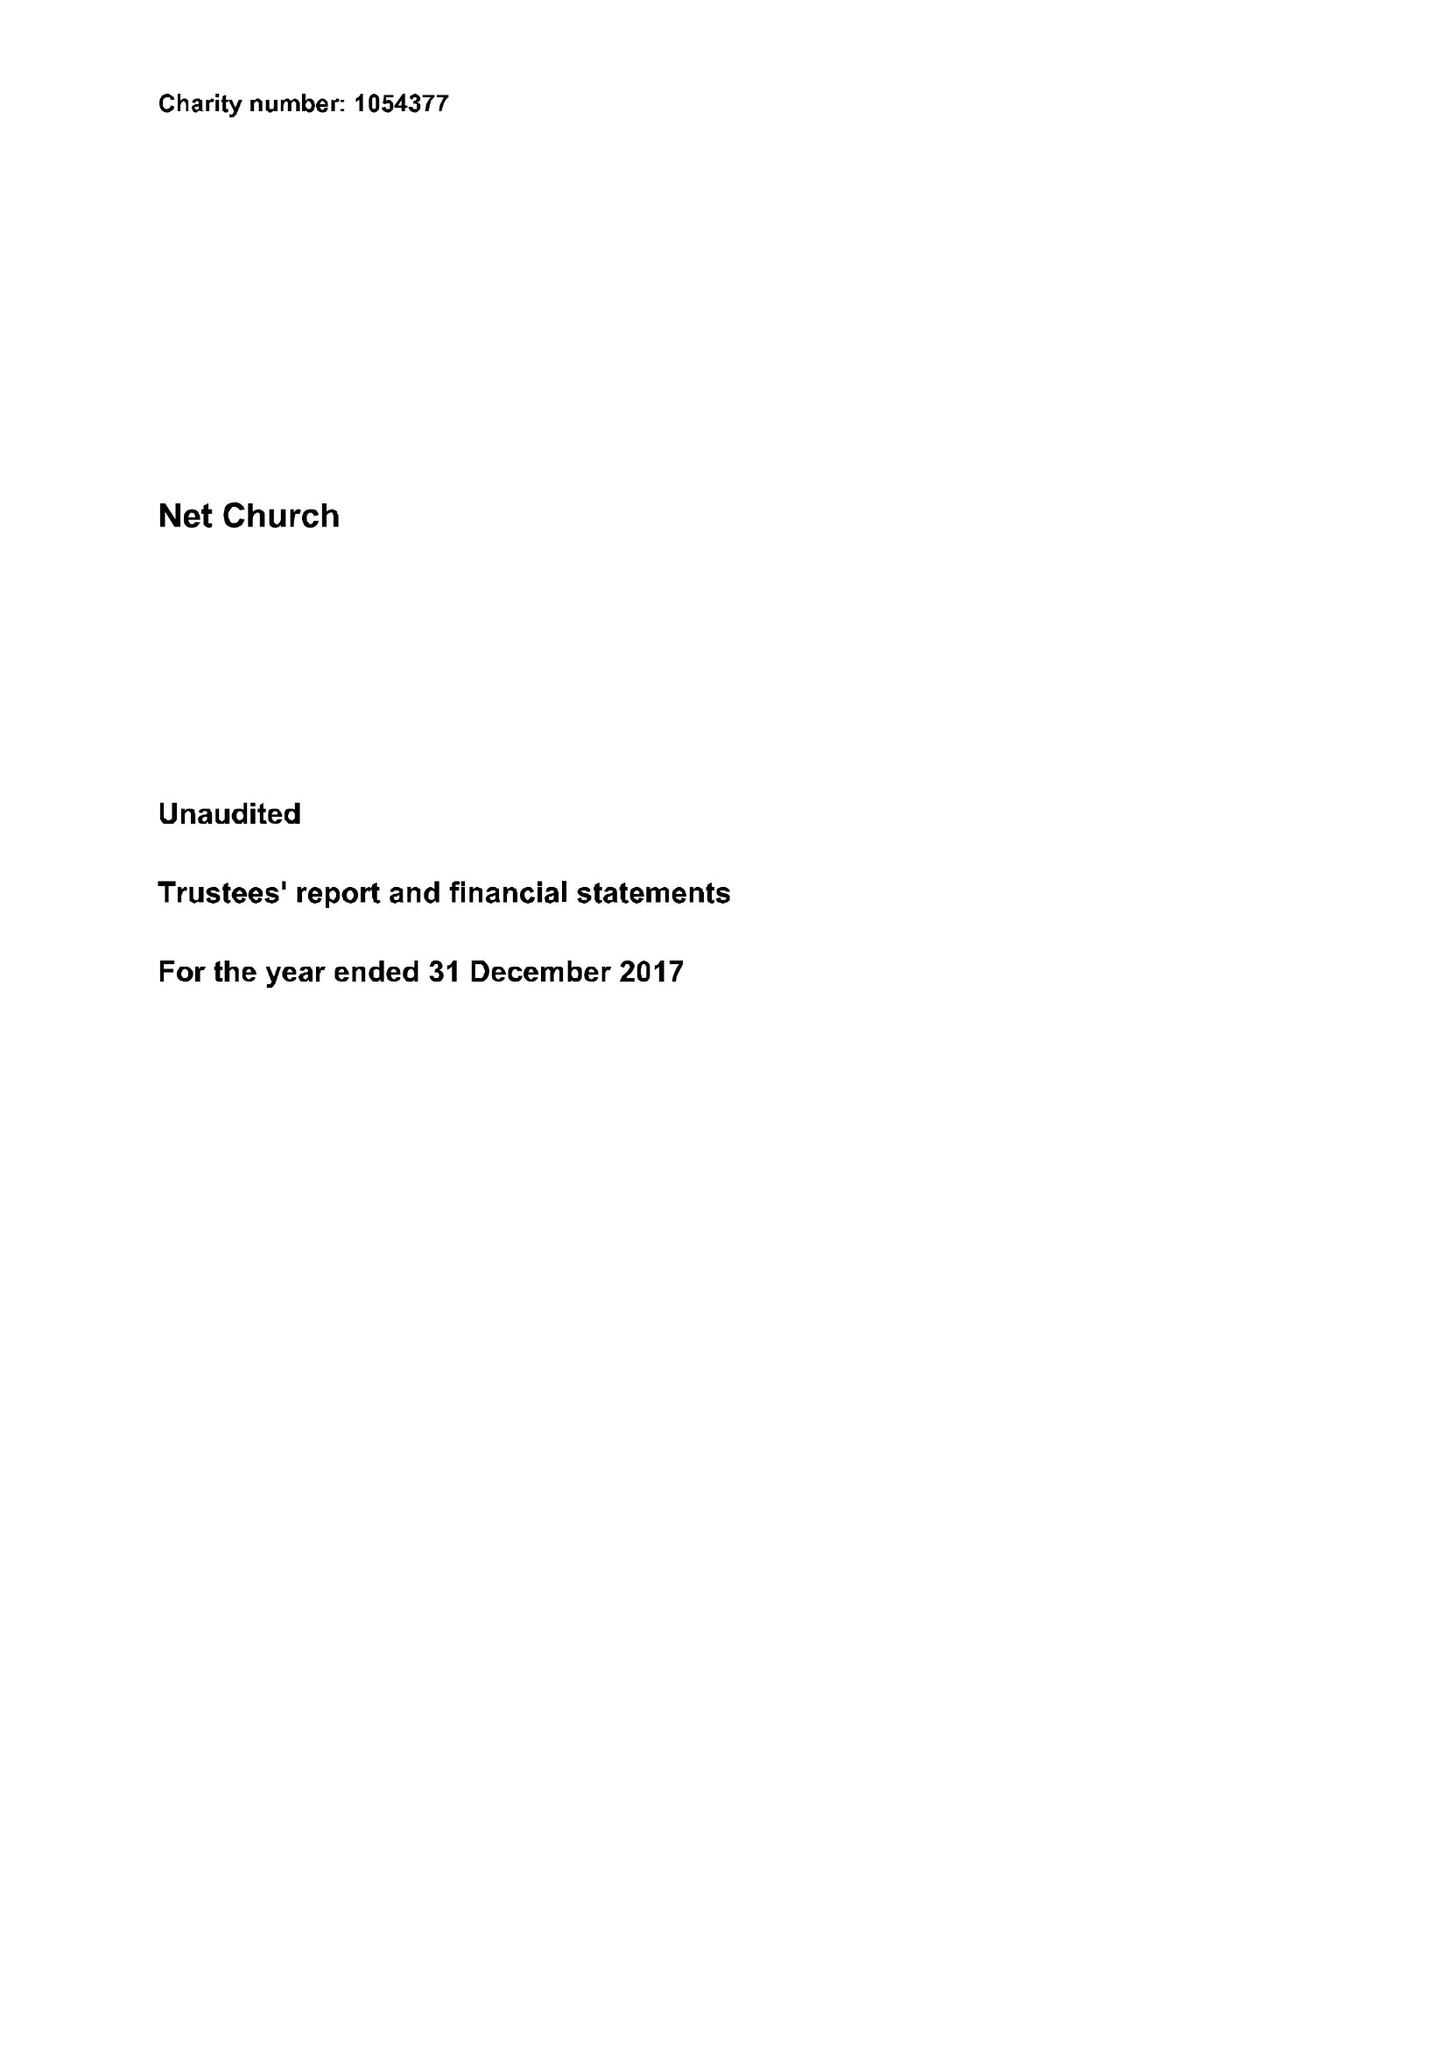What is the value for the address__post_town?
Answer the question using a single word or phrase. SITTINGBOURNE 